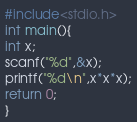<code> <loc_0><loc_0><loc_500><loc_500><_C_>#include<stdio.h>
int main(){
int x;
scanf("%d",&x);
printf("%d\n",x*x*x);
return 0;
}</code> 